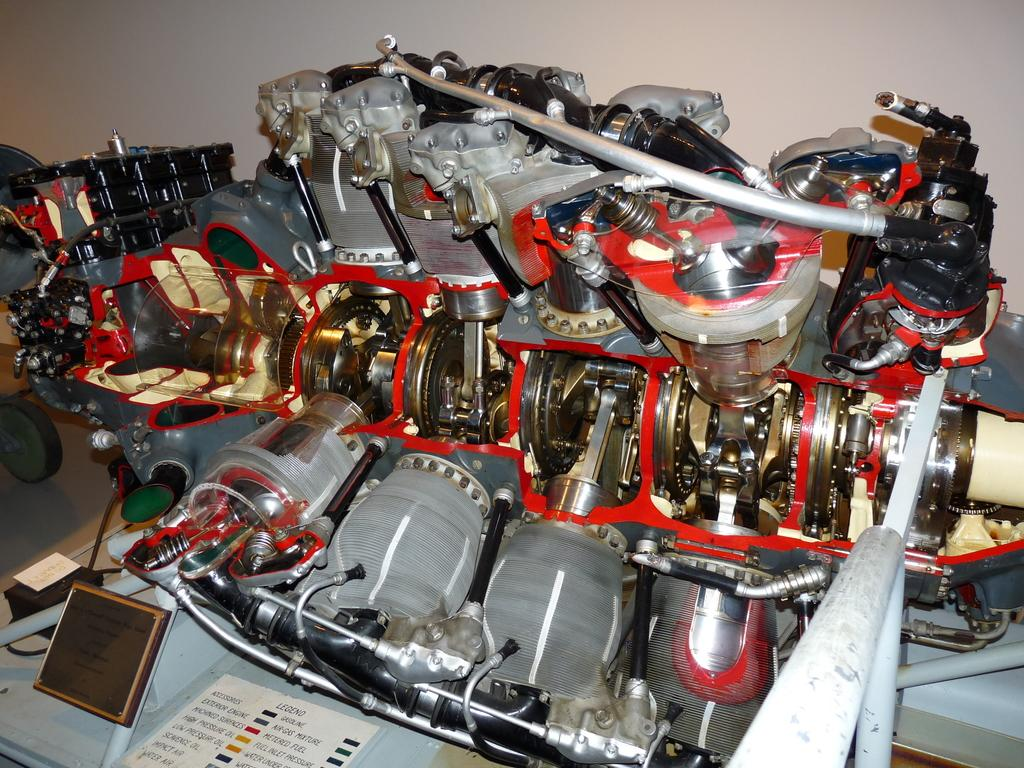What is the main object in the image? There is a machine with a screen in the image. What is attached to the machine? A paper is pasted on the machine, and something is written on it. What are some features of the machine? The machine has pipes and bolts. What can be seen in the background of the image? There is a wall in the background of the image. How does the wind affect the machine in the image? There is no wind present in the image, so it cannot affect the machine. What type of wealth is depicted on the machine? There is no wealth depicted on the machine; it is a machine with a screen, paper, pipes, and bolts. 